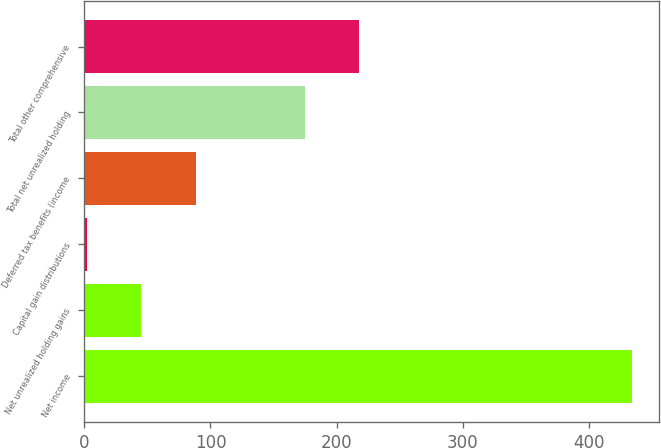Convert chart. <chart><loc_0><loc_0><loc_500><loc_500><bar_chart><fcel>Net income<fcel>Net unrealized holding gains<fcel>Capital gain distributions<fcel>Deferred tax benefits (income<fcel>Total net unrealized holding<fcel>Total other comprehensive<nl><fcel>433.6<fcel>45.16<fcel>2<fcel>88.32<fcel>174.64<fcel>217.8<nl></chart> 